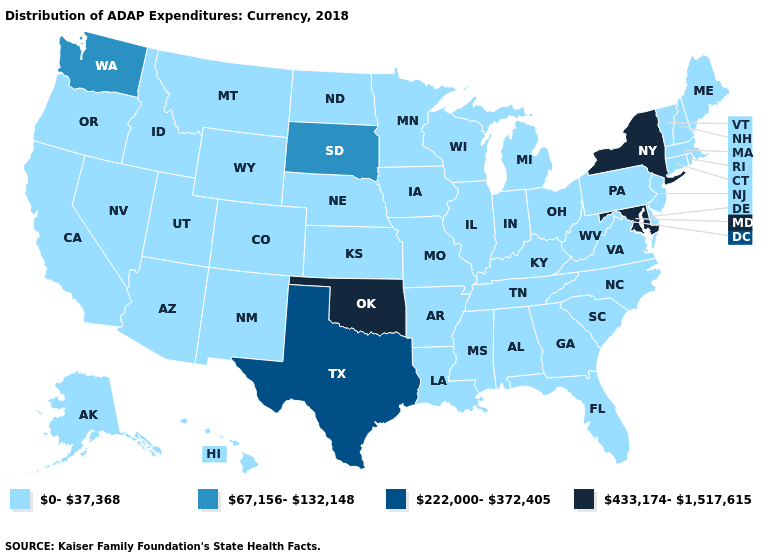Name the states that have a value in the range 67,156-132,148?
Write a very short answer. South Dakota, Washington. What is the highest value in the MidWest ?
Give a very brief answer. 67,156-132,148. What is the lowest value in states that border Nebraska?
Concise answer only. 0-37,368. How many symbols are there in the legend?
Write a very short answer. 4. What is the lowest value in the USA?
Short answer required. 0-37,368. What is the value of West Virginia?
Quick response, please. 0-37,368. Does Wyoming have the lowest value in the West?
Write a very short answer. Yes. Name the states that have a value in the range 222,000-372,405?
Concise answer only. Texas. What is the highest value in states that border West Virginia?
Concise answer only. 433,174-1,517,615. Among the states that border Minnesota , which have the highest value?
Answer briefly. South Dakota. Does the first symbol in the legend represent the smallest category?
Quick response, please. Yes. What is the highest value in the South ?
Answer briefly. 433,174-1,517,615. What is the value of Maryland?
Keep it brief. 433,174-1,517,615. What is the highest value in the Northeast ?
Quick response, please. 433,174-1,517,615. What is the lowest value in states that border Utah?
Answer briefly. 0-37,368. 